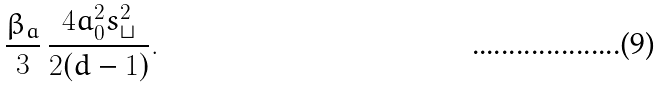Convert formula to latex. <formula><loc_0><loc_0><loc_500><loc_500>\frac { \beta _ { a } } { 3 } \, \frac { 4 a _ { 0 } ^ { 2 } s _ { \sqcup } ^ { 2 } } { 2 ( d - 1 ) } .</formula> 